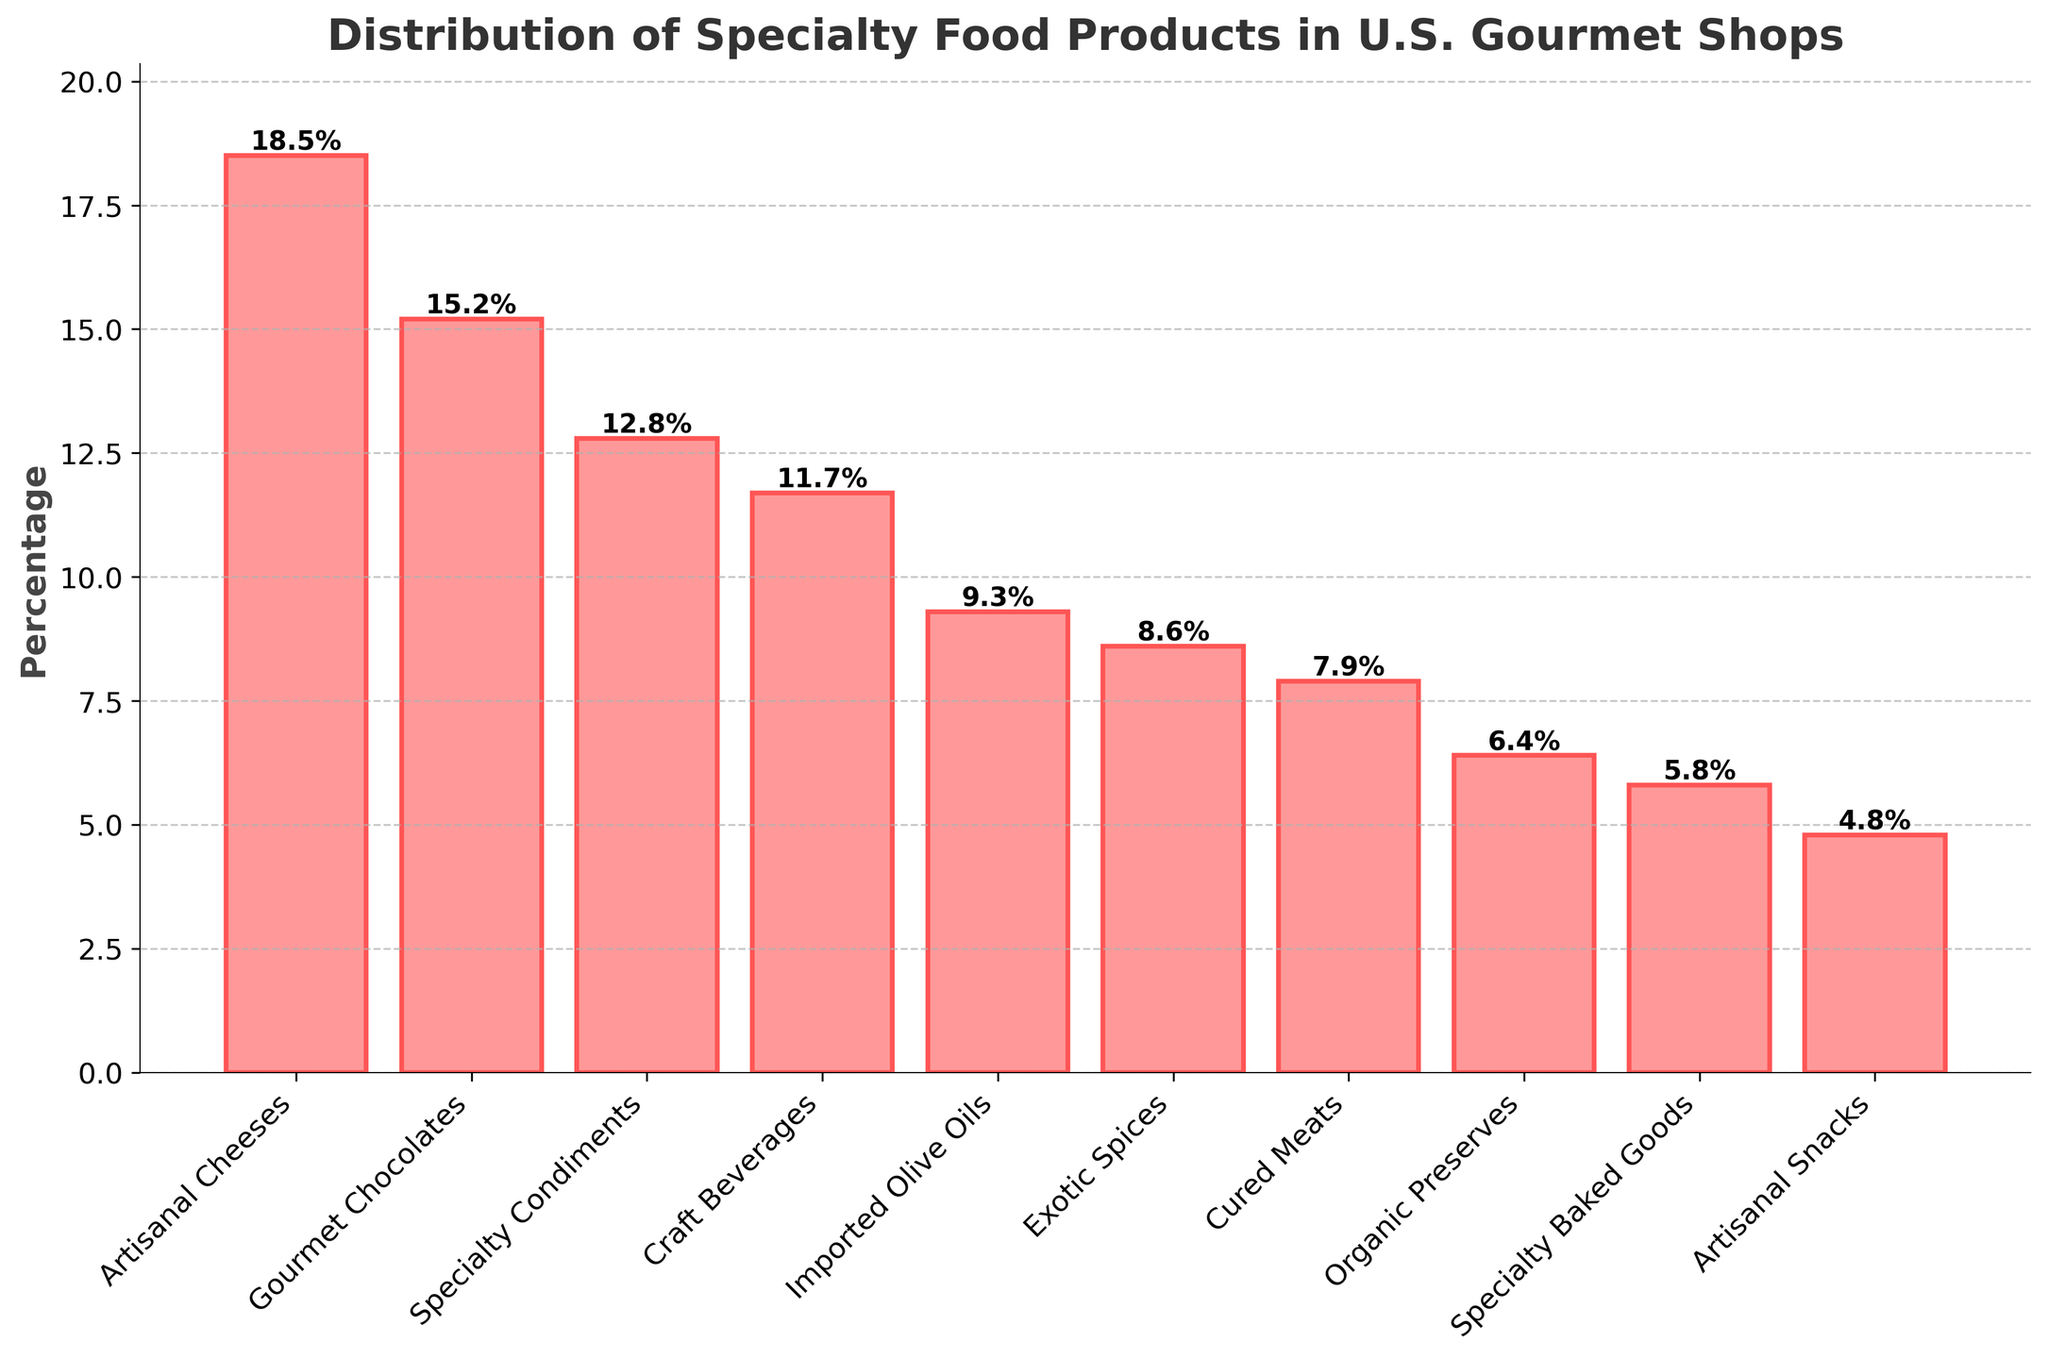What is the most common specialty food product category in U.S. gourmet shops? The tallest bar in the chart represents the most common product category. Here, it is "Artisanal Cheeses" with a percentage of 18.5%
Answer: Artisanal Cheeses Which product category has the lowest representation in U.S. gourmet shops? The shortest bar on the chart indicates the category with the lowest percentage. "Artisanal Snacks" has the smallest percentage at 4.8%
Answer: Artisanal Snacks How much more common are Artisanal Cheeses compared to Cured Meats? To find the difference, subtract the percentage of Cured Meats (7.9%) from Artisanal Cheeses (18.5%) which is 18.5 - 7.9 = 10.6%
Answer: 10.6% Which two categories have a combined percentage close to that of Artisanal Cheeses? By adding the percentages of different categories, we find that the combined percentage of "Gourmet Chocolates" (15.2%) and "Artisanal Snacks" (4.8%) equals 20.0%, which is close but slightly higher than 18.5% for Artisanal Cheeses
Answer: Gourmet Chocolates and Artisanal Snacks What is the average percentage representation of all the specialty food product categories? Sum up all percentages and divide by the number of categories. (18.5 + 15.2 + 12.8 + 11.7 + 9.3 + 8.6 + 7.9 + 6.4 + 5.8 + 4.8) / 10 = 100 / 10 = 10.0%
Answer: 10.0% Is the representation of Imported Olive Oils greater than or equal to that of Exotic Spices? Compare the heights of the bars for Imported Olive Oils (9.3%) and Exotic Spices (8.6%), and see that 9.3% is greater than 8.6%
Answer: Greater How do the percentages of Specialty Condiments and Craft Beverages compare? Examine the chart to find Specialty Condiments at 12.8% and Craft Beverages at 11.7% and note that Specialty Condiments are slightly higher.
Answer: Specialty Condiments are higher What is the total percentage representation of Organic Preserves, Specialty Baked Goods, and Artisanal Snacks? Add the percentages of these three categories: 6.4% + 5.8% + 4.8% = 17.0%
Answer: 17.0% Which category has roughly double the percentage representation of Artisanal Snacks? Find a category that is about twice the percentage of Artisanal Snacks (4.8%). "Imported Olive Oils" at 9.3% is approximately double.
Answer: Imported Olive Oils Which category lies just below Artisanal Cheeses in representation? The bar just below Artisanal Cheeses (18.5%) is Gourmet Chocolates with 15.2%
Answer: Gourmet Chocolates 